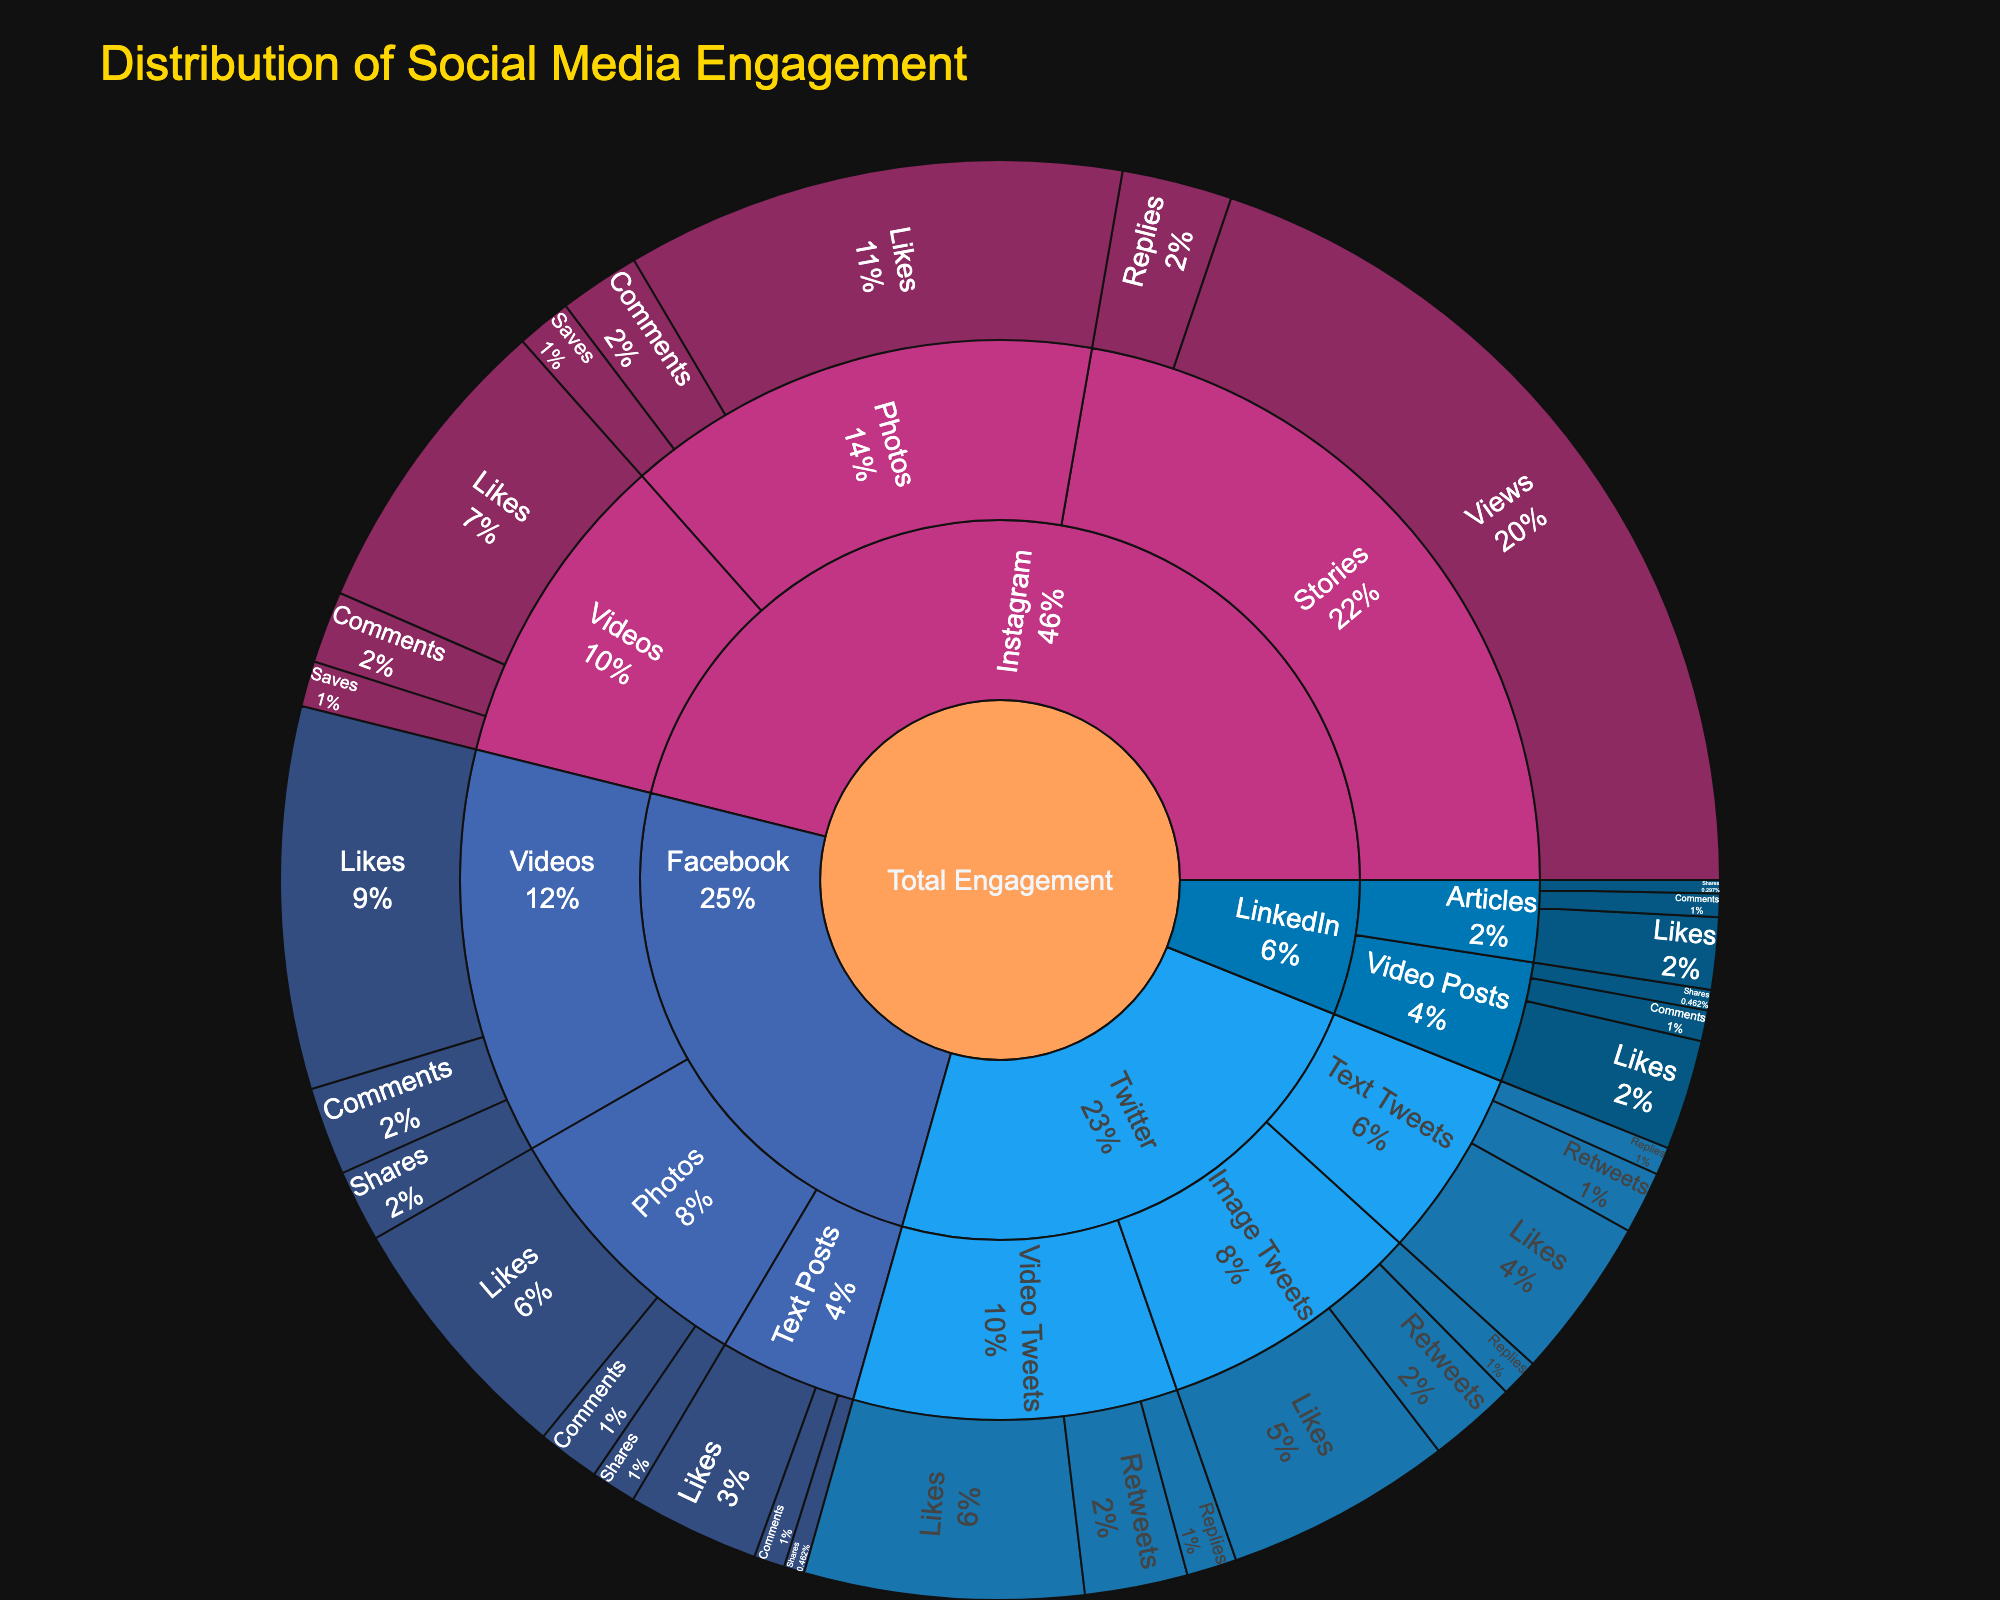How many platforms are represented in the plot? The Sunburst Plot displays different sections for each platform under the 'Total Engagement' root. By counting the distinct sections directly under 'Total Engagement', we can determine the number of platforms.
Answer: 4 Which platform has the highest engagement for photos based on the size of the segments? The size of the segments for each content type under each platform indicates the engagement value. Observing the segments for photos under both Facebook and Instagram, we can see which one is larger.
Answer: Instagram How does the engagement for likes compare between Instagram Stories and Twitter Video Tweets? First, locate the segments for 'Likes' under 'Instagram > Stories' and 'Twitter > Video Tweets'. Then, compare the size of these segments.
Answer: Instagram Stories do not have 'Likes'; Twitter Video Tweets have 3800 likes What is the total engagement for comments across all LinkedIn content types? Identify and sum the segments for 'Comments' under all content types for LinkedIn: Articles (320) and Video Posts (420). Adding these values gives the total.
Answer: 740 In which platform-content type combination is the engagement for 'Shares' the highest? Check the 'Shares' segments across all platform-content type combinations. Compare the sizes of these segments to find the largest one.
Answer: Facebook Videos Are there more comments on Instagram Videos or Facebook Videos? Check the 'Comments' segments under 'Instagram > Videos' and 'Facebook > Videos'. Compare the sizes or values to determine which is higher.
Answer: Facebook Videos How does the engagement for 'Saves' on Instagram Photos compare to that on Instagram Videos? Locate and compare the size of the 'Saves' segments under 'Instagram > Photos' (750) and 'Instagram > Videos' (620).
Answer: Instagram Photos have more saves Which type of content on Twitter has the most likes? Check the 'Likes' segments under each content type for Twitter: Text Tweets (2200), Image Tweets (3100), and Video Tweets (3800). Compare these values to find the highest one.
Answer: Video Tweets What is the proportion of Facebook Text Posts in the overall engagement? Sum the values for all engagement types under 'Facebook > Text Posts' (1800 + 420 + 280 = 2500). Then calculate this as a proportion of the total engagement by summing all segments in the plot.
Answer: The exact proportion requires calculating using full data, approximated as 2500 / (sum of all values) Which engagement type has the highest value on the entire Sunburst Plot? Scan all segments across all platforms, content types, and engagement types to find the one with the largest value.
Answer: Instagram Stories Views 